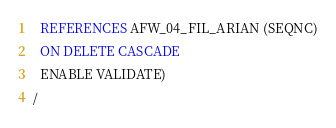Convert code to text. <code><loc_0><loc_0><loc_500><loc_500><_SQL_>  REFERENCES AFW_04_FIL_ARIAN (SEQNC)
  ON DELETE CASCADE
  ENABLE VALIDATE)
/
</code> 